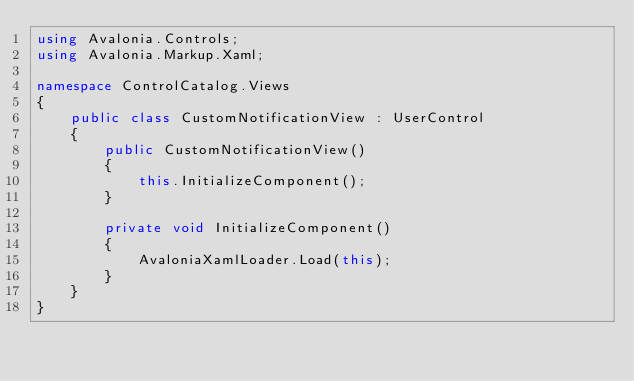Convert code to text. <code><loc_0><loc_0><loc_500><loc_500><_C#_>using Avalonia.Controls;
using Avalonia.Markup.Xaml;

namespace ControlCatalog.Views
{
    public class CustomNotificationView : UserControl
    {
        public CustomNotificationView()
        {
            this.InitializeComponent();
        }

        private void InitializeComponent()
        {
            AvaloniaXamlLoader.Load(this);
        }
    }
}
</code> 